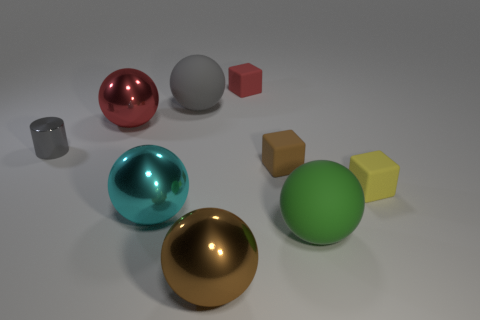What size is the red thing that is the same material as the small brown thing? The red object appears to be a medium-sized cube. It is larger than the small brown cube near it, and they appear to be of the same matte material. 